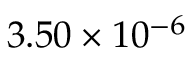<formula> <loc_0><loc_0><loc_500><loc_500>3 . 5 0 \times 1 0 ^ { - 6 }</formula> 